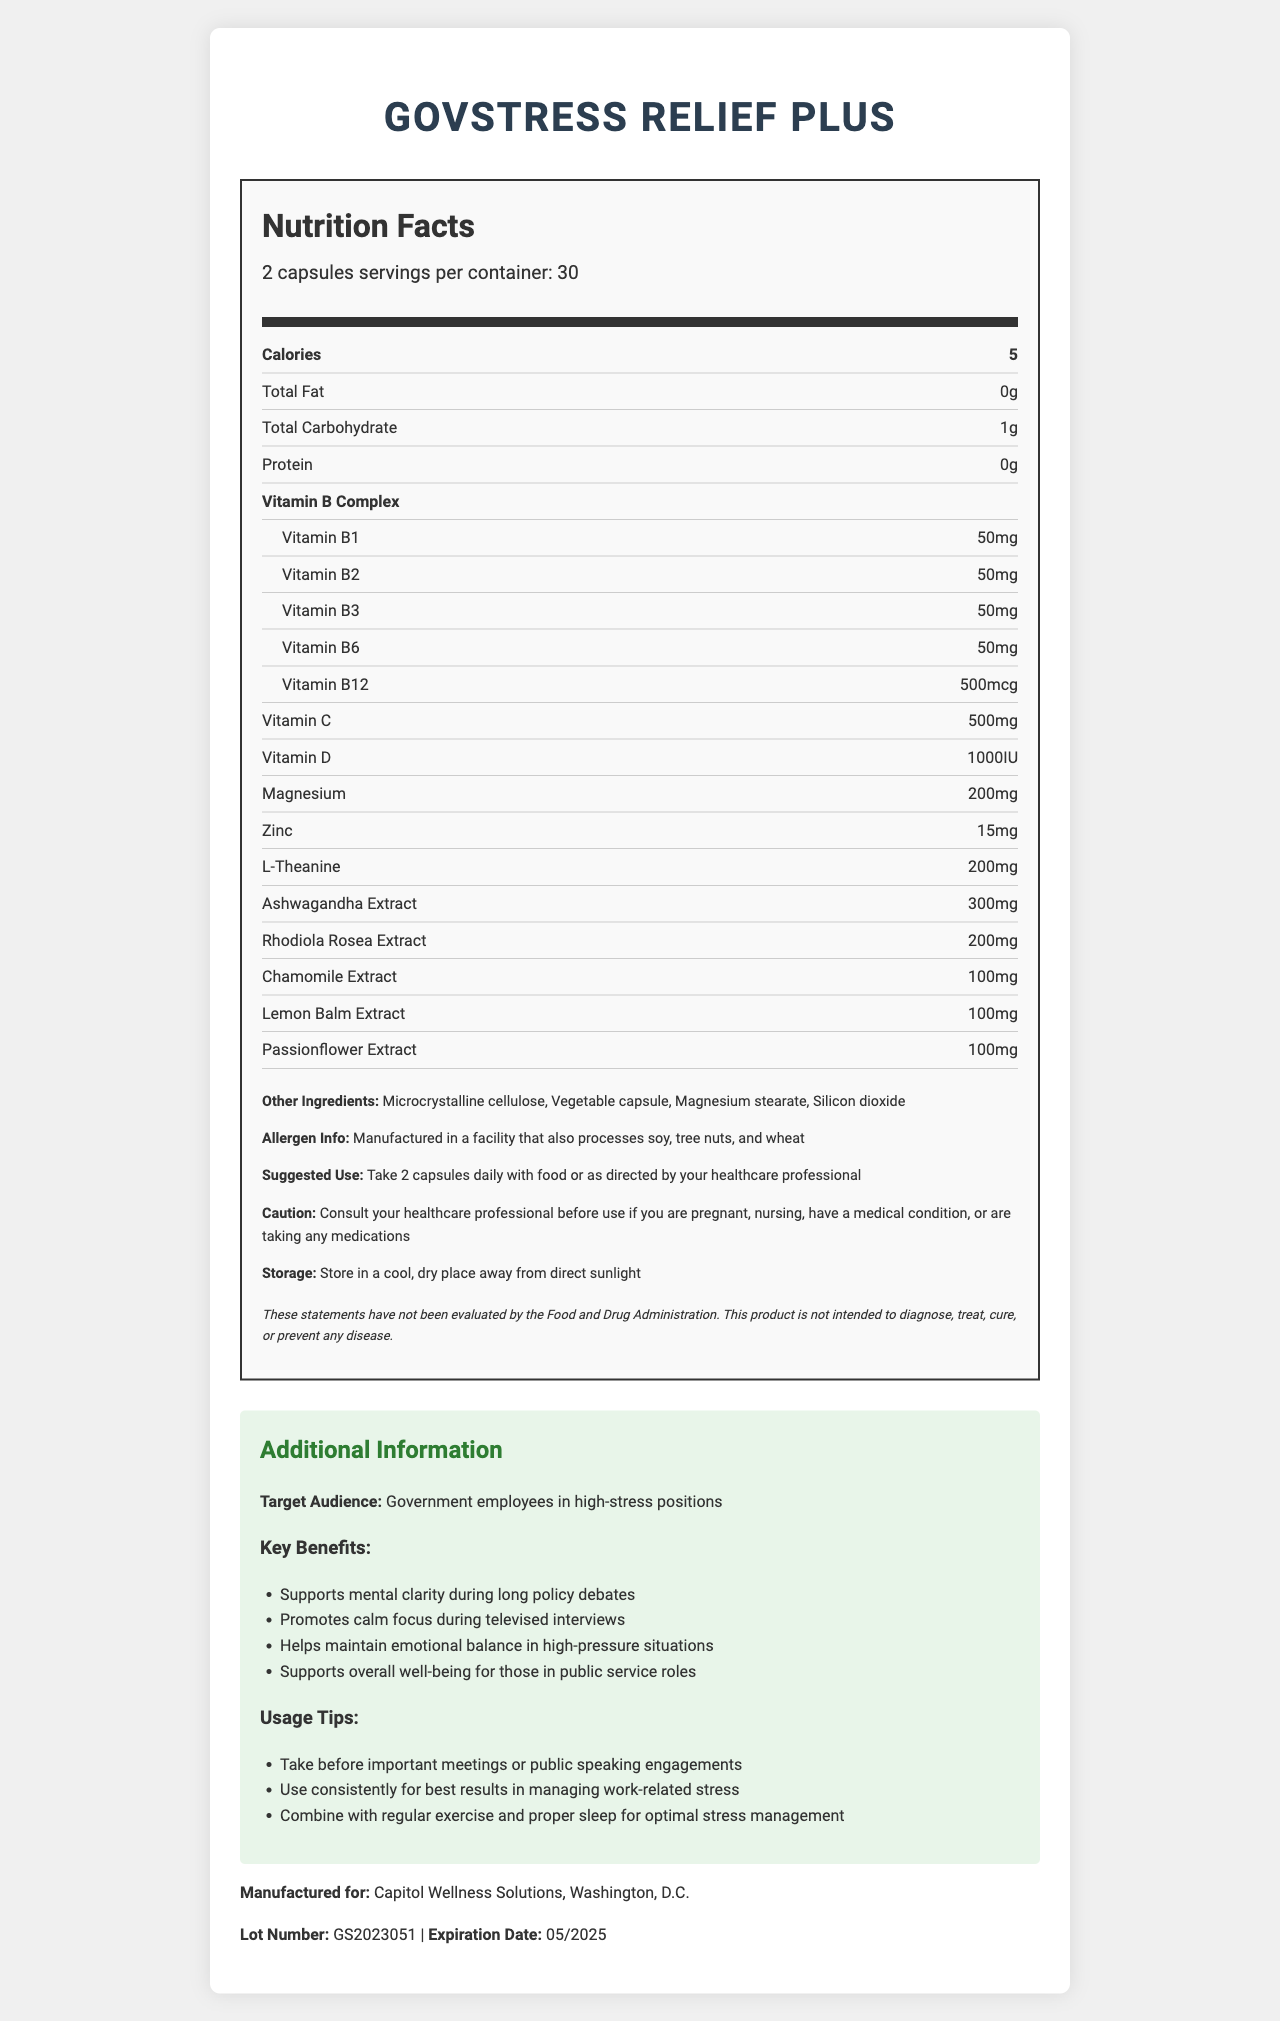what is the serving size? The serving size is mentioned at the beginning of the nutrition facts label as "serving size: 2 capsules".
Answer: 2 capsules how many calories are in each serving? The number of calories per serving is indicated as 5 on the nutrition facts label.
Answer: 5 what is the amount of vitamin B12 per serving? Under the vitamin B complex section, the amount of vitamin B12 per serving is listed as 500 mcg.
Answer: 500 mcg how much magnesium is present in the supplement? The magnesium content per serving is clearly stated as 200 mg in the nutrition facts.
Answer: 200 mg what is the suggested use for this supplement? The suggested use is mentioned in the ingredients section which states to take 2 capsules daily with food or as directed by your healthcare professional.
Answer: Take 2 capsules daily with food or as directed by your healthcare professional what is one of the key benefits of the supplement? One of the key benefits listed in the additional information section is that it supports mental clarity during long policy debates.
Answer: Supports mental clarity during long policy debates the supplement is designed for which target audience? The target audience mentioned in the additional information section is government employees in high-stress positions.
Answer: Government employees in high-stress positions where should this supplement be stored? The storage information advises to store the supplement in a cool, dry place away from direct sunlight.
Answer: Store in a cool, dry place away from direct sunlight does the product contain any protein? The protein content is listed as 0g, indicating there is no protein in the product.
Answer: No what should you do before using this product if you are pregnant or nursing? A. Take it with an additional supplement B. Consult your healthcare professional C. Increase the dosage to 3 capsules D. Discontinue regular diet The caution section advises to consult your healthcare professional before use if you are pregnant, nursing, have a medical condition, or are taking any medications.
Answer: B what is the expiration date of the product? A. 05/2024 B. 05/2026 C. 05/2025 D. 05/2023 The expiration date listed at the end of the document is 05/2025.
Answer: C is the product intended to diagnose, treat, cure, or prevent any disease? Yes/No The disclaimer clearly states that the product is not intended to diagnose, treat, cure, or prevent any disease.
Answer: No summarize the main purpose and content of this document. The document contains specifics about the contents and benefits of the supplement, targeted at government employees in stressful roles, and provides careful usage instructions, storage guidelines, and safety precautions.
Answer: This document provides detailed nutrition facts and usage information about "GovStress Relief Plus", a vitamin supplement designed to support stress management in high-pressure government roles. It includes nutrition information like vitamins and minerals, suggested use, caution, allergen info, storage instructions, and additional benefits for its target audience, along with disclaimers and manufacturing details. what is the percentage of daily value for each vitamin? The document does not provide the percentage of daily value for each vitamin, only the amounts in mg or IU.
Answer: Not enough information 